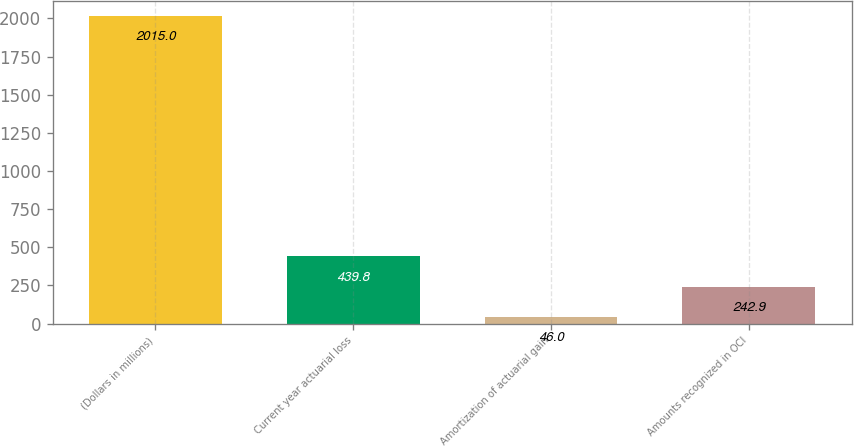<chart> <loc_0><loc_0><loc_500><loc_500><bar_chart><fcel>(Dollars in millions)<fcel>Current year actuarial loss<fcel>Amortization of actuarial gain<fcel>Amounts recognized in OCI<nl><fcel>2015<fcel>439.8<fcel>46<fcel>242.9<nl></chart> 